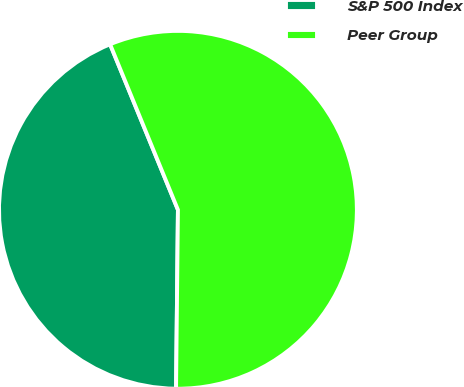Convert chart. <chart><loc_0><loc_0><loc_500><loc_500><pie_chart><fcel>S&P 500 Index<fcel>Peer Group<nl><fcel>43.64%<fcel>56.36%<nl></chart> 